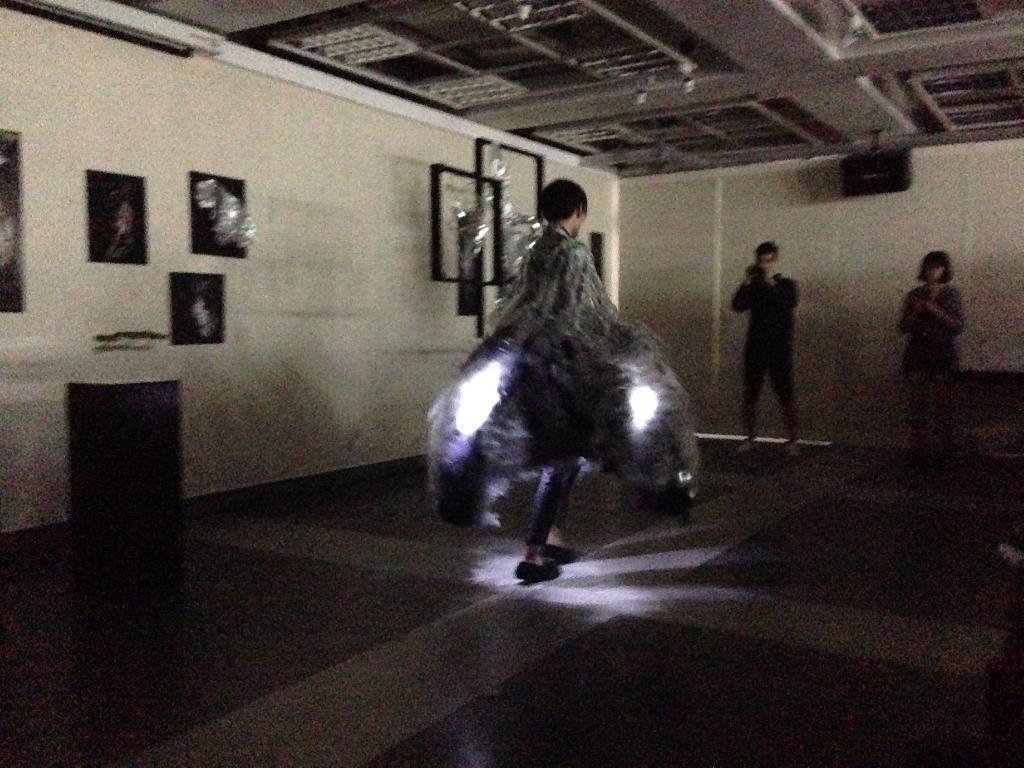Can you describe this image briefly? This picture shows a woman walking and we see a man holding a camera and we see another woman standing on the side and we see few photo frames on the wall and a cupboard on the side. 